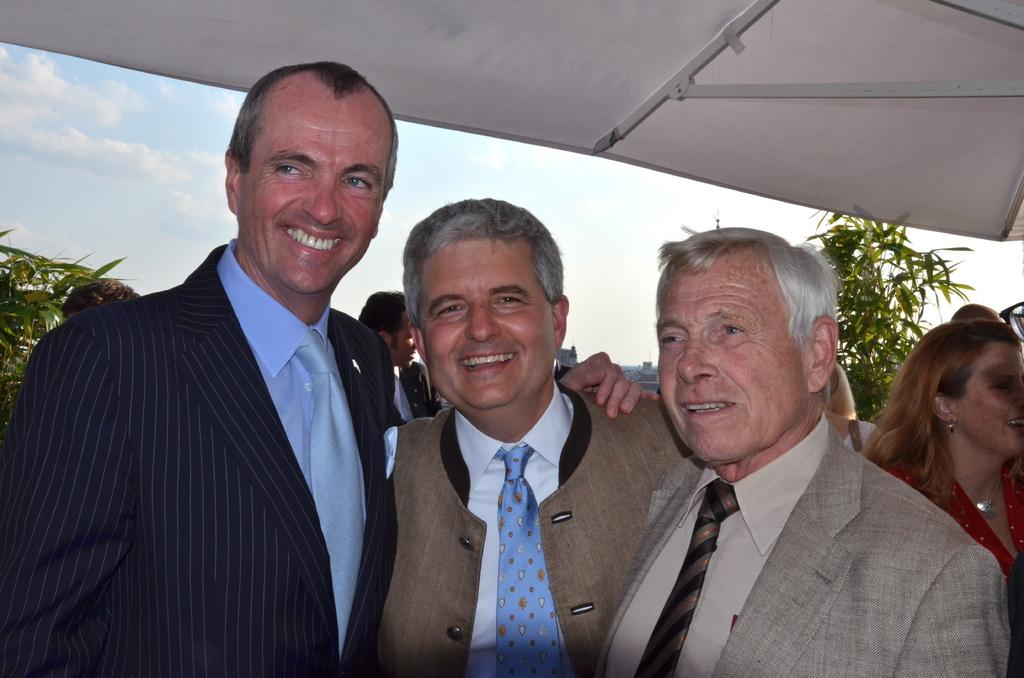Who or what can be seen in the image? There are people in the image. What is the white object in the image? There is a white object in the image, but its specific nature is not mentioned in the facts. What type of natural environment is visible in the image? There are trees in the image, indicating a natural environment. How would you describe the weather in the image? The sky is cloudy in the image, suggesting overcast or potentially rainy weather. What is the emotional state of the people in the front of the image? The people in the front of the image are smiling, indicating a positive or happy emotional state. What type of cloth is being used to connect the trees in the image? There is no mention of any cloth or connection between the trees in the image. 